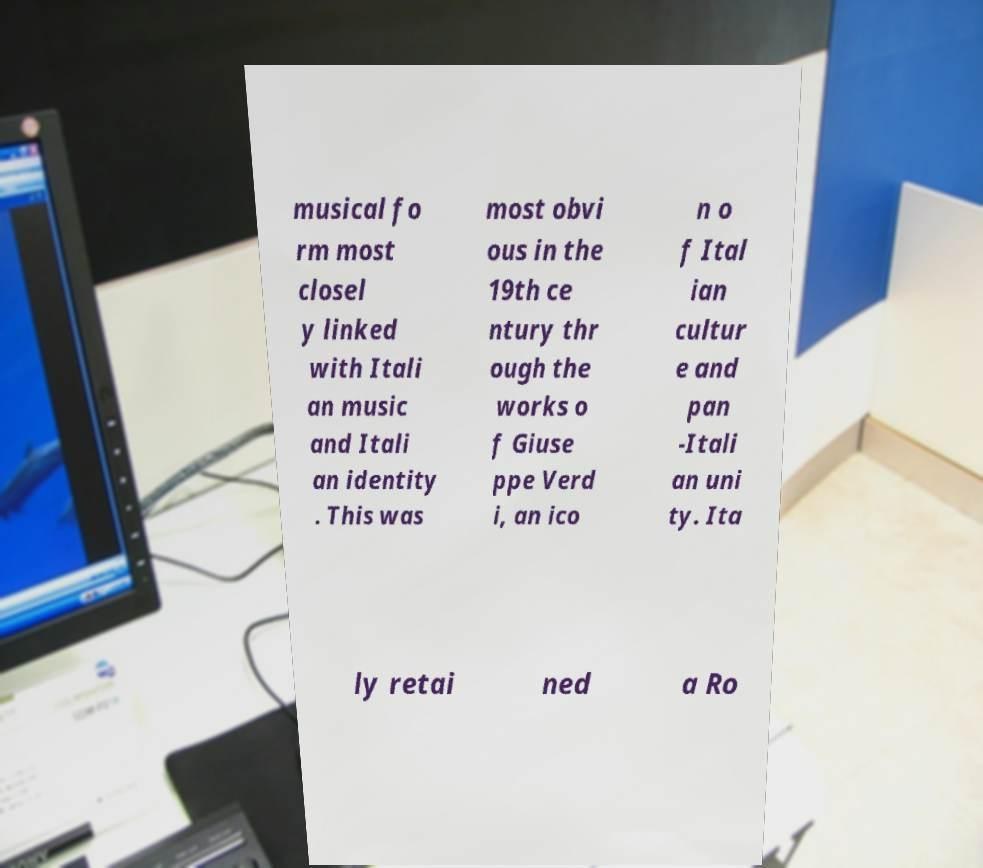Can you accurately transcribe the text from the provided image for me? musical fo rm most closel y linked with Itali an music and Itali an identity . This was most obvi ous in the 19th ce ntury thr ough the works o f Giuse ppe Verd i, an ico n o f Ital ian cultur e and pan -Itali an uni ty. Ita ly retai ned a Ro 